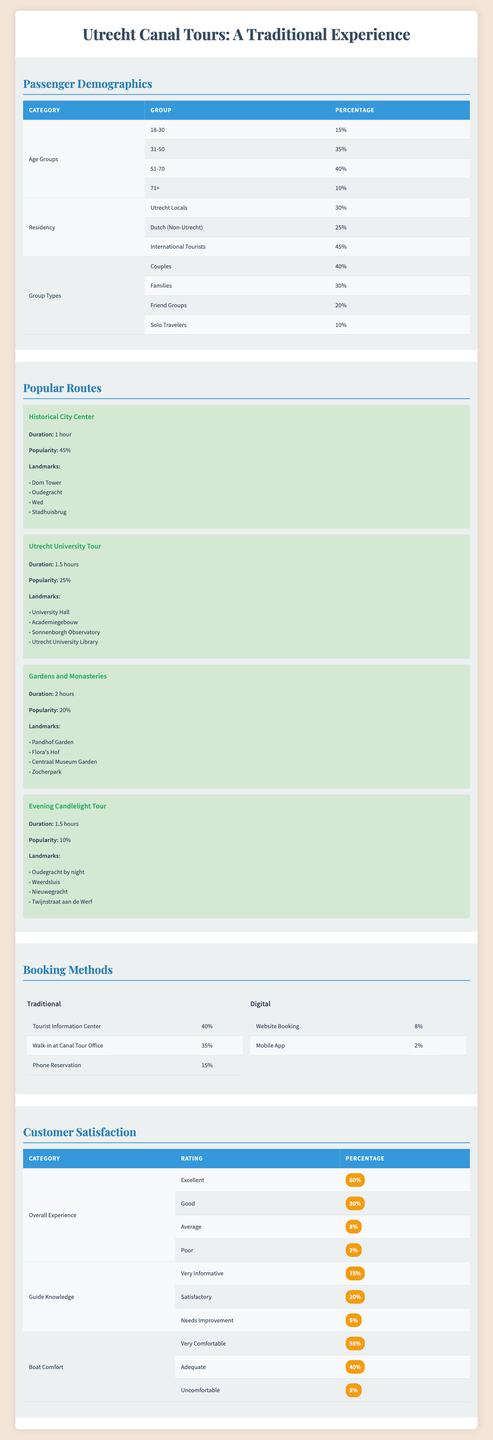What percentage of passengers are aged 51-70? The table shows that the age group 51-70 accounts for 40% of passengers in the canal tours.
Answer: 40% What is the most popular route among the canal tours? The "Historical City Center" route has the highest popularity rating at 45%, which is more than any other route presented.
Answer: Historical City Center What is the total percentage of Utrecht locals and Dutch (non-Utrecht) residents among the passengers? Adding the percentages of Utrecht locals (30%) and Dutch (non-Utrecht) residents (25%) gives a total of 55%.
Answer: 55% Do more people prefer traditional booking methods over digital ones? The traditional booking methods together account for 90% (40% + 35% + 15%), while digital booking is only 10% (8% + 2%), confirming that more people prefer traditional methods.
Answer: Yes What percentage of families are among the canal tour passengers? The table indicates that families make up 30% of the total passenger demographics.
Answer: 30% What is the difference in popularity between the "Utrecht University Tour" and the "Evening Candlelight Tour"? The popularity of the "Utrecht University Tour" is 25%, and for the "Evening Candlelight Tour," it is 10%. The difference is 25% - 10% = 15%.
Answer: 15% What is the overall percentage of passengers who rated their experience as either excellent or good? Adding the percentages of excellent (60%) and good (30%) ratings gives a total of 90%.
Answer: 90% Is the percentage of solo travelers higher than that of families? Families account for 30% while solo travelers only make up 10%. Therefore, it is false that solo travelers are higher.
Answer: No Which type of group has the least representation among passengers? The table shows that solo travelers have the lowest percentage, at 10%, compared to all other group types.
Answer: Solo Travelers What percentage of the passengers feel very comfortable on the boat? The data states that 55% of passengers rated their boat comfort as very comfortable.
Answer: 55% 